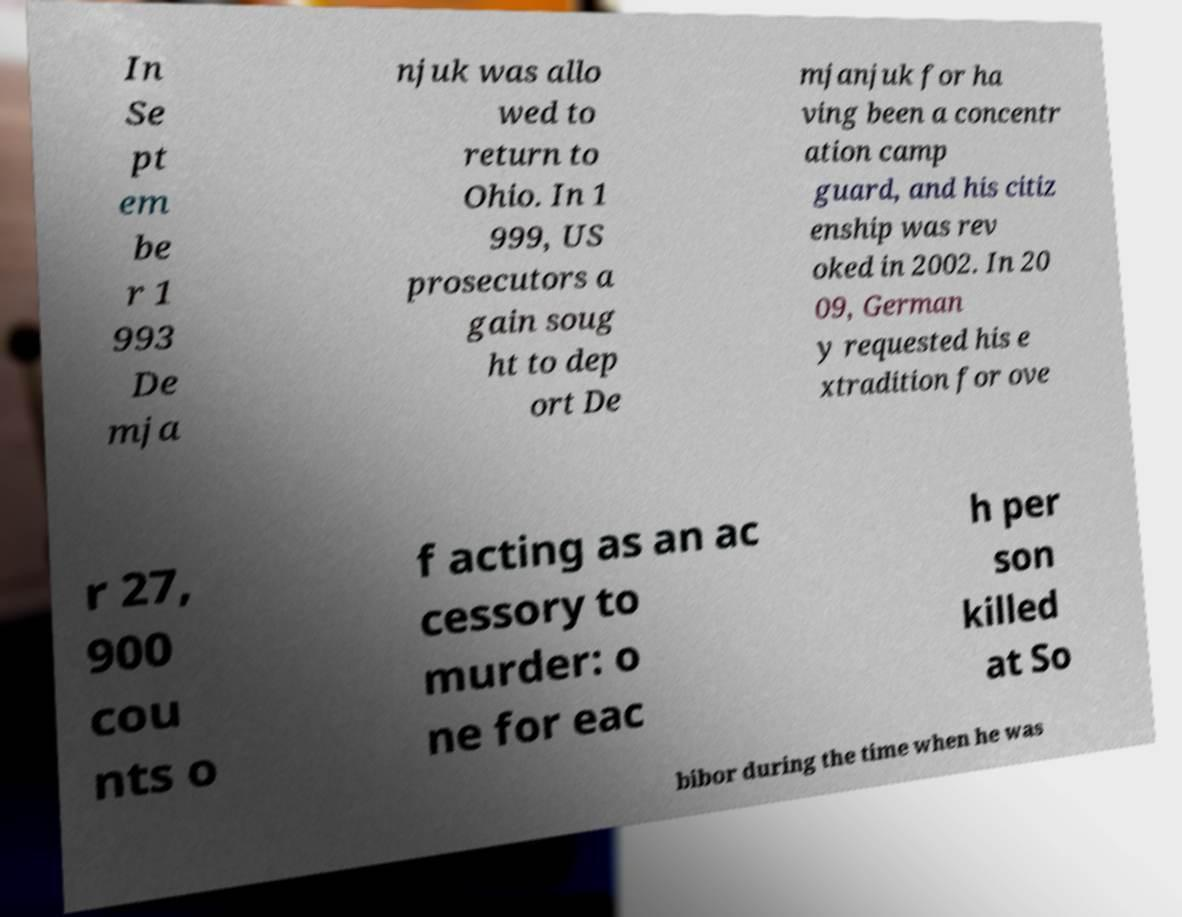What messages or text are displayed in this image? I need them in a readable, typed format. In Se pt em be r 1 993 De mja njuk was allo wed to return to Ohio. In 1 999, US prosecutors a gain soug ht to dep ort De mjanjuk for ha ving been a concentr ation camp guard, and his citiz enship was rev oked in 2002. In 20 09, German y requested his e xtradition for ove r 27, 900 cou nts o f acting as an ac cessory to murder: o ne for eac h per son killed at So bibor during the time when he was 